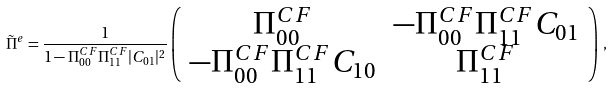<formula> <loc_0><loc_0><loc_500><loc_500>\tilde { \Pi } ^ { e } = \frac { 1 } { 1 - \Pi ^ { C F } _ { 0 0 } \Pi ^ { C F } _ { 1 1 } | C _ { 0 1 } | ^ { 2 } } \left ( \begin{array} { c c } \Pi ^ { C F } _ { 0 0 } & - \Pi ^ { C F } _ { 0 0 } \Pi ^ { C F } _ { 1 1 } C _ { 0 1 } \\ - \Pi ^ { C F } _ { 0 0 } \Pi ^ { C F } _ { 1 1 } C _ { 1 0 } & \Pi ^ { C F } _ { 1 1 } \end{array} \right ) \, ,</formula> 